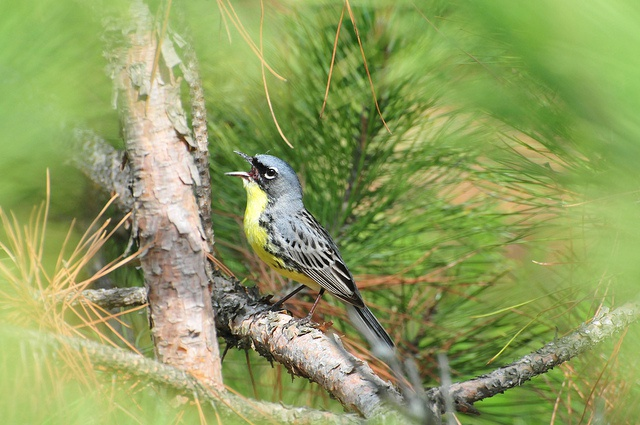Describe the objects in this image and their specific colors. I can see a bird in lightgreen, darkgray, black, gray, and lightgray tones in this image. 